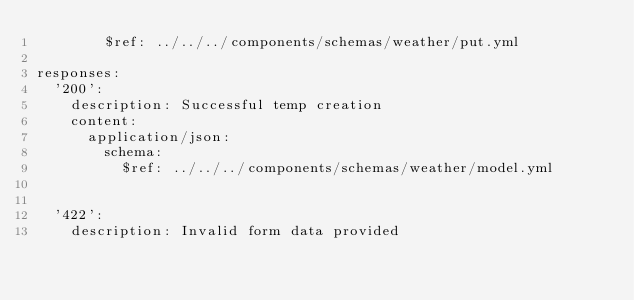<code> <loc_0><loc_0><loc_500><loc_500><_YAML_>        $ref: ../../../components/schemas/weather/put.yml
    
responses:
  '200':
    description: Successful temp creation
    content: 
      application/json:
        schema:
          $ref: ../../../components/schemas/weather/model.yml
      
      
  '422':
    description: Invalid form data provided
</code> 